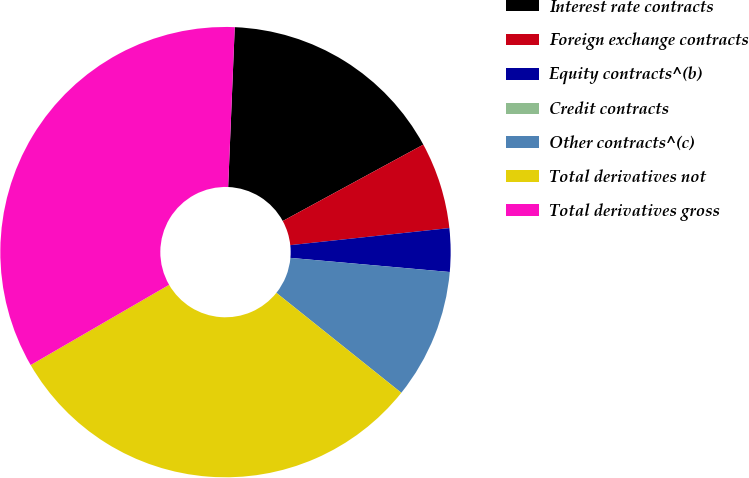<chart> <loc_0><loc_0><loc_500><loc_500><pie_chart><fcel>Interest rate contracts<fcel>Foreign exchange contracts<fcel>Equity contracts^(b)<fcel>Credit contracts<fcel>Other contracts^(c)<fcel>Total derivatives not<fcel>Total derivatives gross<nl><fcel>16.42%<fcel>6.22%<fcel>3.11%<fcel>0.0%<fcel>9.33%<fcel>30.9%<fcel>34.01%<nl></chart> 